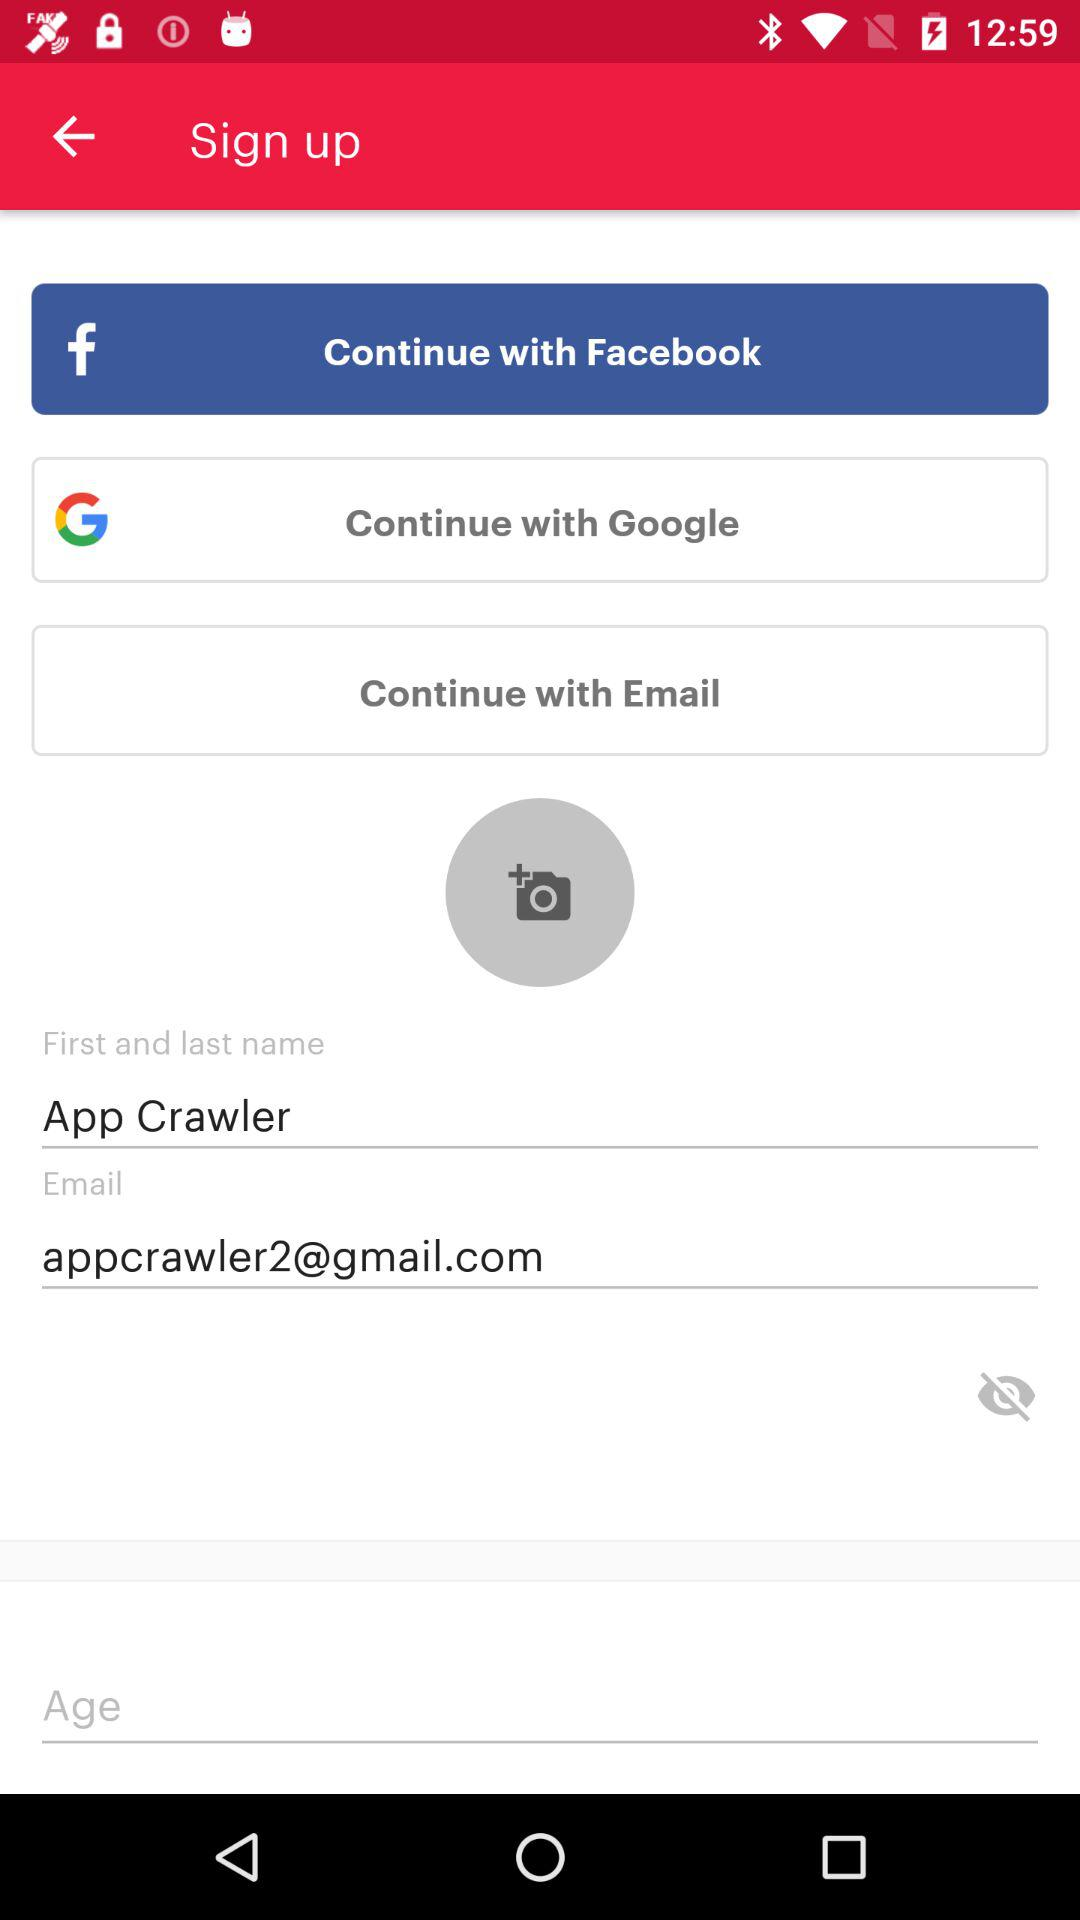What is the name of the user? The name of the user is App Crawler. 